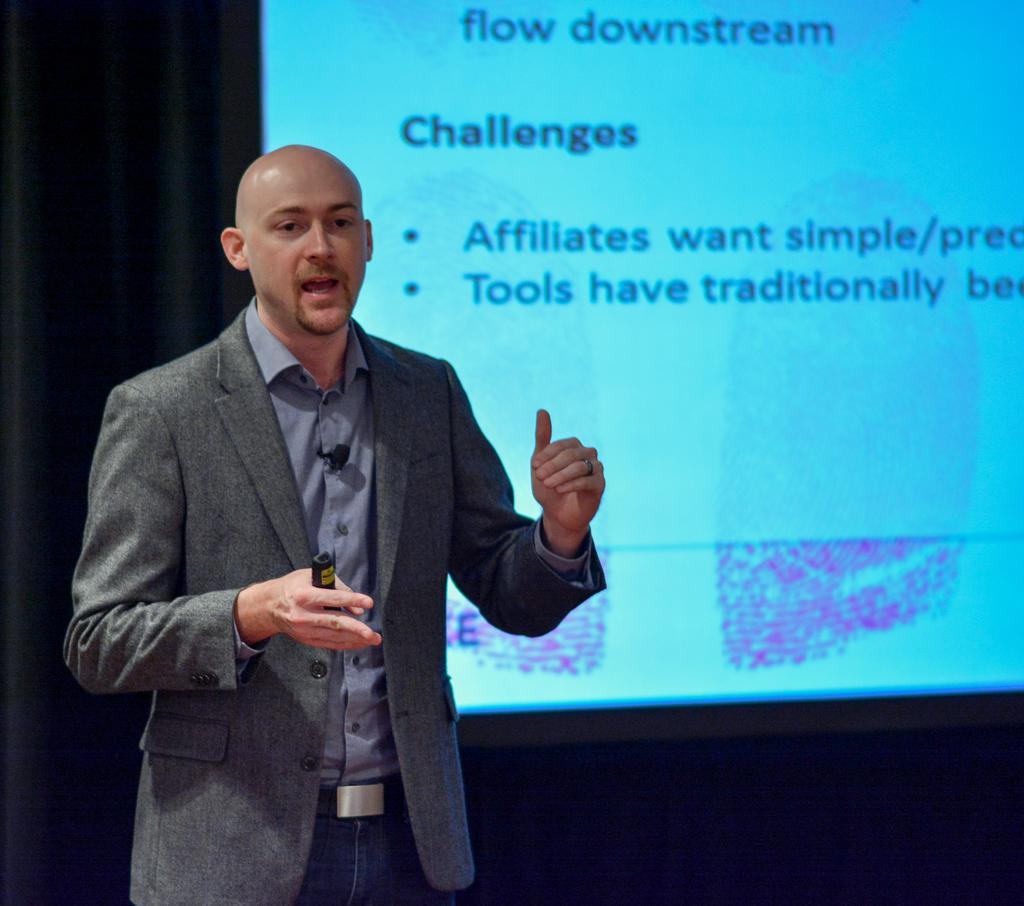Please provide a concise description of this image. In this image, on the left side, we can see a man standing, he is wearing a coat and holding an object in his hand. We can see the projector screen in the background. 